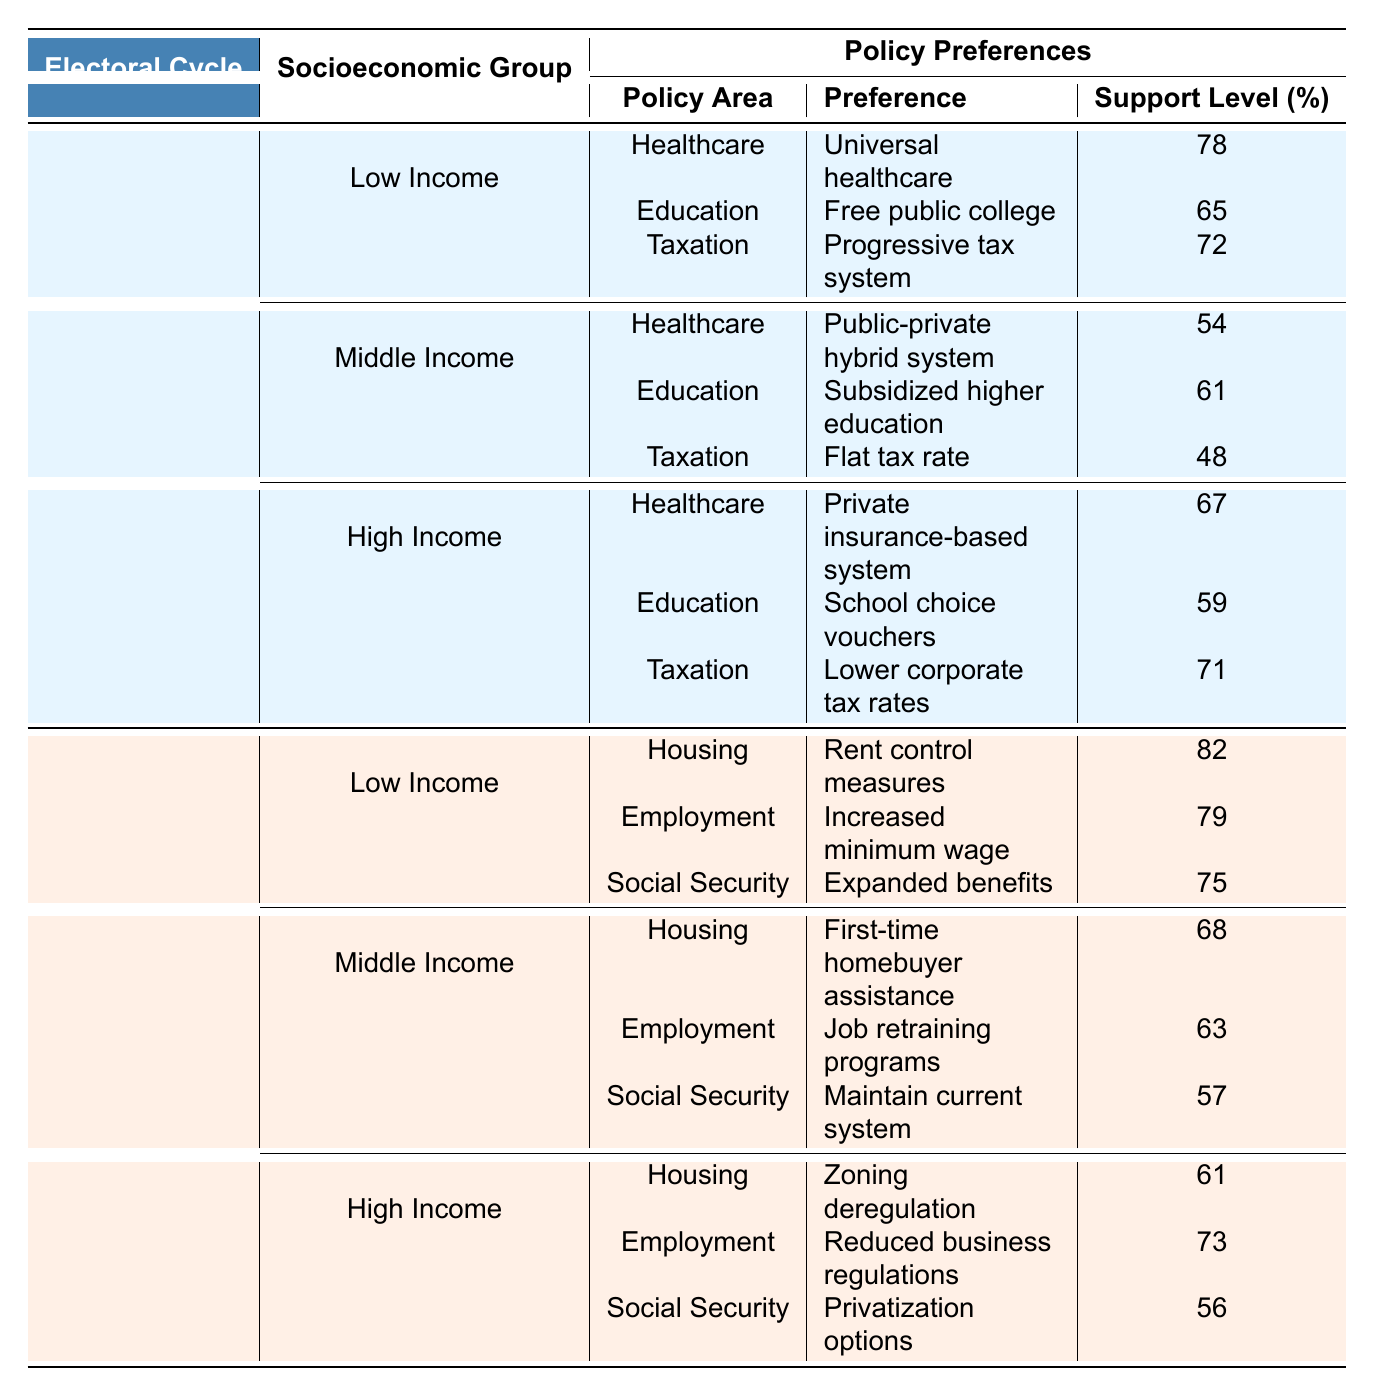What is the highest support level for healthcare preferences in the 2016-2020 cycle? The table shows that among the Low Income group, the preference for universal healthcare has the highest support level of 78 in the 2016-2020 cycle.
Answer: 78 Which socioeconomic group has the lowest support level for taxation preferences in the 2016-2020 cycle? Reviewing the Middle Income group, their flat tax rate preference has the lowest support level of 48 for taxation in the 2016-2020 cycle.
Answer: Middle Income What is the percentage difference in support level for social security preferences between Low Income and High Income groups in the 2020-2024 cycle? The Low Income group supports expanded benefits at 75%, while the High Income group prefers privatization options at 56%. The percentage difference is calculated as 75 - 56 = 19.
Answer: 19 Does the Middle Income group show a higher preference for education support in the 2016-2020 cycle compared to the High Income group? The Middle Income group has a support level of 61 for subsidized higher education, while the High Income group has 59 for school choice vouchers. Thus, the Middle Income group shows a higher preference.
Answer: Yes What is the overall average support level for housing preferences across all socioeconomic groups in the 2020-2024 cycle? Summing the support levels for housing preferences: 82 (Low Income) + 68 (Middle Income) + 61 (High Income) = 211. There are 3 groups, so the average is 211 / 3 = 70.33.
Answer: 70.33 Which policy area has the highest support among the Low Income group in the 2020-2024 cycle? Among the Low Income group's preferences in the 2020-2024 cycle, rent control measures hold the highest support level of 82.
Answer: 82 What percentage of Middle Income respondents prefer job retraining programs over maintaining the current social security system in the 2020-2024 cycle? The preference for job retraining programs is supported by 63%, while maintaining the current system is supported by 57%. The difference is 63 - 57 = 6%.
Answer: 6% Is the trend in the support level for the healthcare policy area improving from 2016-2020 to 2020-2024 for Low Income groups? In the 2016-2020 cycle, the support level for healthcare (universal healthcare) is 78, while the 2020-2024 cycle does not show a healthcare preference for Low Income groups. Hence, we cannot conclude a trend based on the provided data.
Answer: No What was the support level for the taxation preference in the High Income group during the 2016-2020 cycle? The High Income group showed a support level of 71 for the lower corporate tax rates preference in the 2016-2020 cycle.
Answer: 71 How does the support level for employment preferences compare between Low Income and High Income groups in the 2020-2024 cycle? Low Income support for increased minimum wage is at 79, while High Income support for reduced business regulations is at 73. Thus, Low Income has higher support by 6.
Answer: 6 